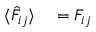<formula> <loc_0><loc_0><loc_500><loc_500>\begin{array} { r l } { \langle \hat { F } _ { i j } \rangle } & = F _ { i j } } \end{array}</formula> 